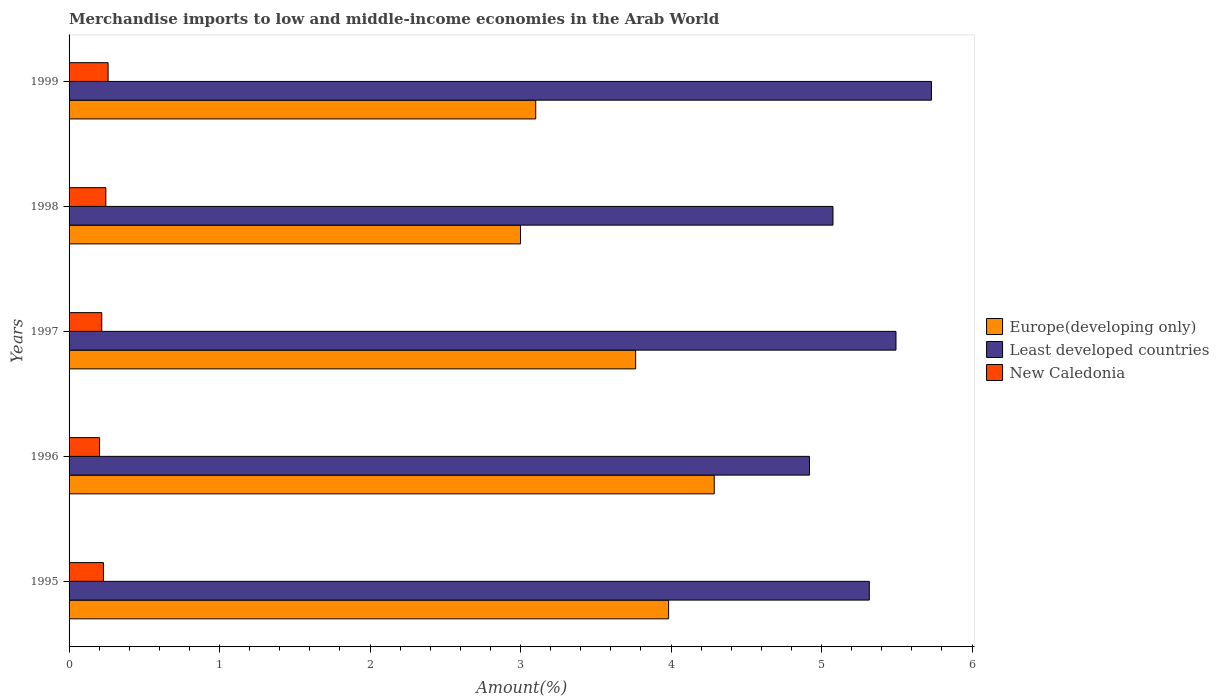How many different coloured bars are there?
Your answer should be very brief. 3. Are the number of bars per tick equal to the number of legend labels?
Your answer should be compact. Yes. Are the number of bars on each tick of the Y-axis equal?
Ensure brevity in your answer.  Yes. How many bars are there on the 5th tick from the top?
Give a very brief answer. 3. What is the label of the 5th group of bars from the top?
Provide a succinct answer. 1995. In how many cases, is the number of bars for a given year not equal to the number of legend labels?
Give a very brief answer. 0. What is the percentage of amount earned from merchandise imports in Europe(developing only) in 1997?
Your response must be concise. 3.76. Across all years, what is the maximum percentage of amount earned from merchandise imports in New Caledonia?
Your answer should be very brief. 0.26. Across all years, what is the minimum percentage of amount earned from merchandise imports in Europe(developing only)?
Offer a very short reply. 3. In which year was the percentage of amount earned from merchandise imports in Europe(developing only) maximum?
Offer a terse response. 1996. In which year was the percentage of amount earned from merchandise imports in New Caledonia minimum?
Provide a short and direct response. 1996. What is the total percentage of amount earned from merchandise imports in Least developed countries in the graph?
Offer a terse response. 26.54. What is the difference between the percentage of amount earned from merchandise imports in Europe(developing only) in 1998 and that in 1999?
Provide a succinct answer. -0.1. What is the difference between the percentage of amount earned from merchandise imports in Europe(developing only) in 1996 and the percentage of amount earned from merchandise imports in New Caledonia in 1997?
Make the answer very short. 4.07. What is the average percentage of amount earned from merchandise imports in Least developed countries per year?
Make the answer very short. 5.31. In the year 1996, what is the difference between the percentage of amount earned from merchandise imports in New Caledonia and percentage of amount earned from merchandise imports in Europe(developing only)?
Make the answer very short. -4.08. What is the ratio of the percentage of amount earned from merchandise imports in New Caledonia in 1997 to that in 1998?
Ensure brevity in your answer.  0.89. Is the percentage of amount earned from merchandise imports in Least developed countries in 1995 less than that in 1997?
Ensure brevity in your answer.  Yes. Is the difference between the percentage of amount earned from merchandise imports in New Caledonia in 1998 and 1999 greater than the difference between the percentage of amount earned from merchandise imports in Europe(developing only) in 1998 and 1999?
Make the answer very short. Yes. What is the difference between the highest and the second highest percentage of amount earned from merchandise imports in Europe(developing only)?
Offer a very short reply. 0.3. What is the difference between the highest and the lowest percentage of amount earned from merchandise imports in New Caledonia?
Keep it short and to the point. 0.06. In how many years, is the percentage of amount earned from merchandise imports in Least developed countries greater than the average percentage of amount earned from merchandise imports in Least developed countries taken over all years?
Your response must be concise. 3. Is the sum of the percentage of amount earned from merchandise imports in Europe(developing only) in 1998 and 1999 greater than the maximum percentage of amount earned from merchandise imports in Least developed countries across all years?
Your answer should be compact. Yes. What does the 3rd bar from the top in 1997 represents?
Make the answer very short. Europe(developing only). What does the 2nd bar from the bottom in 1999 represents?
Offer a very short reply. Least developed countries. Are all the bars in the graph horizontal?
Provide a short and direct response. Yes. How many years are there in the graph?
Provide a succinct answer. 5. What is the difference between two consecutive major ticks on the X-axis?
Your answer should be compact. 1. Are the values on the major ticks of X-axis written in scientific E-notation?
Keep it short and to the point. No. Does the graph contain any zero values?
Offer a very short reply. No. Does the graph contain grids?
Give a very brief answer. No. What is the title of the graph?
Offer a terse response. Merchandise imports to low and middle-income economies in the Arab World. What is the label or title of the X-axis?
Make the answer very short. Amount(%). What is the Amount(%) of Europe(developing only) in 1995?
Provide a short and direct response. 3.98. What is the Amount(%) in Least developed countries in 1995?
Provide a succinct answer. 5.32. What is the Amount(%) of New Caledonia in 1995?
Offer a very short reply. 0.23. What is the Amount(%) in Europe(developing only) in 1996?
Provide a succinct answer. 4.29. What is the Amount(%) of Least developed countries in 1996?
Keep it short and to the point. 4.92. What is the Amount(%) of New Caledonia in 1996?
Your response must be concise. 0.2. What is the Amount(%) in Europe(developing only) in 1997?
Offer a terse response. 3.76. What is the Amount(%) of Least developed countries in 1997?
Your answer should be compact. 5.49. What is the Amount(%) in New Caledonia in 1997?
Provide a short and direct response. 0.22. What is the Amount(%) of Europe(developing only) in 1998?
Your answer should be very brief. 3. What is the Amount(%) in Least developed countries in 1998?
Offer a terse response. 5.08. What is the Amount(%) of New Caledonia in 1998?
Provide a short and direct response. 0.24. What is the Amount(%) in Europe(developing only) in 1999?
Provide a short and direct response. 3.1. What is the Amount(%) in Least developed countries in 1999?
Keep it short and to the point. 5.73. What is the Amount(%) in New Caledonia in 1999?
Provide a succinct answer. 0.26. Across all years, what is the maximum Amount(%) in Europe(developing only)?
Your answer should be compact. 4.29. Across all years, what is the maximum Amount(%) in Least developed countries?
Your answer should be compact. 5.73. Across all years, what is the maximum Amount(%) in New Caledonia?
Your answer should be compact. 0.26. Across all years, what is the minimum Amount(%) of Europe(developing only)?
Make the answer very short. 3. Across all years, what is the minimum Amount(%) in Least developed countries?
Your response must be concise. 4.92. Across all years, what is the minimum Amount(%) of New Caledonia?
Keep it short and to the point. 0.2. What is the total Amount(%) in Europe(developing only) in the graph?
Provide a succinct answer. 18.14. What is the total Amount(%) of Least developed countries in the graph?
Your answer should be compact. 26.54. What is the total Amount(%) in New Caledonia in the graph?
Provide a succinct answer. 1.15. What is the difference between the Amount(%) of Europe(developing only) in 1995 and that in 1996?
Ensure brevity in your answer.  -0.3. What is the difference between the Amount(%) in Least developed countries in 1995 and that in 1996?
Ensure brevity in your answer.  0.4. What is the difference between the Amount(%) of New Caledonia in 1995 and that in 1996?
Ensure brevity in your answer.  0.03. What is the difference between the Amount(%) in Europe(developing only) in 1995 and that in 1997?
Your answer should be compact. 0.22. What is the difference between the Amount(%) in Least developed countries in 1995 and that in 1997?
Provide a short and direct response. -0.18. What is the difference between the Amount(%) in New Caledonia in 1995 and that in 1997?
Provide a succinct answer. 0.01. What is the difference between the Amount(%) of Europe(developing only) in 1995 and that in 1998?
Keep it short and to the point. 0.98. What is the difference between the Amount(%) of Least developed countries in 1995 and that in 1998?
Make the answer very short. 0.24. What is the difference between the Amount(%) of New Caledonia in 1995 and that in 1998?
Give a very brief answer. -0.02. What is the difference between the Amount(%) in Europe(developing only) in 1995 and that in 1999?
Offer a very short reply. 0.88. What is the difference between the Amount(%) in Least developed countries in 1995 and that in 1999?
Provide a short and direct response. -0.41. What is the difference between the Amount(%) in New Caledonia in 1995 and that in 1999?
Give a very brief answer. -0.03. What is the difference between the Amount(%) in Europe(developing only) in 1996 and that in 1997?
Your response must be concise. 0.52. What is the difference between the Amount(%) in Least developed countries in 1996 and that in 1997?
Your answer should be very brief. -0.57. What is the difference between the Amount(%) of New Caledonia in 1996 and that in 1997?
Your answer should be compact. -0.01. What is the difference between the Amount(%) in Europe(developing only) in 1996 and that in 1998?
Ensure brevity in your answer.  1.29. What is the difference between the Amount(%) of Least developed countries in 1996 and that in 1998?
Your answer should be very brief. -0.16. What is the difference between the Amount(%) in New Caledonia in 1996 and that in 1998?
Provide a short and direct response. -0.04. What is the difference between the Amount(%) in Europe(developing only) in 1996 and that in 1999?
Provide a short and direct response. 1.19. What is the difference between the Amount(%) in Least developed countries in 1996 and that in 1999?
Give a very brief answer. -0.81. What is the difference between the Amount(%) in New Caledonia in 1996 and that in 1999?
Provide a short and direct response. -0.06. What is the difference between the Amount(%) in Europe(developing only) in 1997 and that in 1998?
Your answer should be very brief. 0.77. What is the difference between the Amount(%) of Least developed countries in 1997 and that in 1998?
Offer a terse response. 0.42. What is the difference between the Amount(%) in New Caledonia in 1997 and that in 1998?
Your answer should be compact. -0.03. What is the difference between the Amount(%) in Europe(developing only) in 1997 and that in 1999?
Make the answer very short. 0.66. What is the difference between the Amount(%) of Least developed countries in 1997 and that in 1999?
Give a very brief answer. -0.24. What is the difference between the Amount(%) of New Caledonia in 1997 and that in 1999?
Your answer should be very brief. -0.04. What is the difference between the Amount(%) of Europe(developing only) in 1998 and that in 1999?
Provide a succinct answer. -0.1. What is the difference between the Amount(%) in Least developed countries in 1998 and that in 1999?
Your answer should be very brief. -0.65. What is the difference between the Amount(%) of New Caledonia in 1998 and that in 1999?
Give a very brief answer. -0.01. What is the difference between the Amount(%) in Europe(developing only) in 1995 and the Amount(%) in Least developed countries in 1996?
Provide a succinct answer. -0.94. What is the difference between the Amount(%) in Europe(developing only) in 1995 and the Amount(%) in New Caledonia in 1996?
Your response must be concise. 3.78. What is the difference between the Amount(%) in Least developed countries in 1995 and the Amount(%) in New Caledonia in 1996?
Provide a succinct answer. 5.12. What is the difference between the Amount(%) of Europe(developing only) in 1995 and the Amount(%) of Least developed countries in 1997?
Give a very brief answer. -1.51. What is the difference between the Amount(%) of Europe(developing only) in 1995 and the Amount(%) of New Caledonia in 1997?
Your answer should be compact. 3.77. What is the difference between the Amount(%) of Least developed countries in 1995 and the Amount(%) of New Caledonia in 1997?
Make the answer very short. 5.1. What is the difference between the Amount(%) of Europe(developing only) in 1995 and the Amount(%) of Least developed countries in 1998?
Give a very brief answer. -1.09. What is the difference between the Amount(%) of Europe(developing only) in 1995 and the Amount(%) of New Caledonia in 1998?
Offer a terse response. 3.74. What is the difference between the Amount(%) in Least developed countries in 1995 and the Amount(%) in New Caledonia in 1998?
Your answer should be compact. 5.07. What is the difference between the Amount(%) of Europe(developing only) in 1995 and the Amount(%) of Least developed countries in 1999?
Your answer should be compact. -1.75. What is the difference between the Amount(%) in Europe(developing only) in 1995 and the Amount(%) in New Caledonia in 1999?
Your answer should be very brief. 3.72. What is the difference between the Amount(%) in Least developed countries in 1995 and the Amount(%) in New Caledonia in 1999?
Your answer should be very brief. 5.06. What is the difference between the Amount(%) of Europe(developing only) in 1996 and the Amount(%) of Least developed countries in 1997?
Your answer should be very brief. -1.21. What is the difference between the Amount(%) in Europe(developing only) in 1996 and the Amount(%) in New Caledonia in 1997?
Your answer should be compact. 4.07. What is the difference between the Amount(%) of Least developed countries in 1996 and the Amount(%) of New Caledonia in 1997?
Offer a terse response. 4.7. What is the difference between the Amount(%) of Europe(developing only) in 1996 and the Amount(%) of Least developed countries in 1998?
Your response must be concise. -0.79. What is the difference between the Amount(%) of Europe(developing only) in 1996 and the Amount(%) of New Caledonia in 1998?
Provide a succinct answer. 4.04. What is the difference between the Amount(%) in Least developed countries in 1996 and the Amount(%) in New Caledonia in 1998?
Your answer should be compact. 4.68. What is the difference between the Amount(%) of Europe(developing only) in 1996 and the Amount(%) of Least developed countries in 1999?
Your answer should be very brief. -1.44. What is the difference between the Amount(%) of Europe(developing only) in 1996 and the Amount(%) of New Caledonia in 1999?
Provide a short and direct response. 4.03. What is the difference between the Amount(%) of Least developed countries in 1996 and the Amount(%) of New Caledonia in 1999?
Your response must be concise. 4.66. What is the difference between the Amount(%) of Europe(developing only) in 1997 and the Amount(%) of Least developed countries in 1998?
Provide a short and direct response. -1.31. What is the difference between the Amount(%) in Europe(developing only) in 1997 and the Amount(%) in New Caledonia in 1998?
Make the answer very short. 3.52. What is the difference between the Amount(%) in Least developed countries in 1997 and the Amount(%) in New Caledonia in 1998?
Offer a terse response. 5.25. What is the difference between the Amount(%) in Europe(developing only) in 1997 and the Amount(%) in Least developed countries in 1999?
Your response must be concise. -1.97. What is the difference between the Amount(%) of Europe(developing only) in 1997 and the Amount(%) of New Caledonia in 1999?
Keep it short and to the point. 3.51. What is the difference between the Amount(%) of Least developed countries in 1997 and the Amount(%) of New Caledonia in 1999?
Keep it short and to the point. 5.24. What is the difference between the Amount(%) of Europe(developing only) in 1998 and the Amount(%) of Least developed countries in 1999?
Give a very brief answer. -2.73. What is the difference between the Amount(%) of Europe(developing only) in 1998 and the Amount(%) of New Caledonia in 1999?
Your response must be concise. 2.74. What is the difference between the Amount(%) of Least developed countries in 1998 and the Amount(%) of New Caledonia in 1999?
Make the answer very short. 4.82. What is the average Amount(%) in Europe(developing only) per year?
Ensure brevity in your answer.  3.63. What is the average Amount(%) in Least developed countries per year?
Give a very brief answer. 5.31. What is the average Amount(%) in New Caledonia per year?
Offer a terse response. 0.23. In the year 1995, what is the difference between the Amount(%) of Europe(developing only) and Amount(%) of Least developed countries?
Provide a succinct answer. -1.33. In the year 1995, what is the difference between the Amount(%) of Europe(developing only) and Amount(%) of New Caledonia?
Your answer should be compact. 3.76. In the year 1995, what is the difference between the Amount(%) in Least developed countries and Amount(%) in New Caledonia?
Make the answer very short. 5.09. In the year 1996, what is the difference between the Amount(%) of Europe(developing only) and Amount(%) of Least developed countries?
Give a very brief answer. -0.63. In the year 1996, what is the difference between the Amount(%) in Europe(developing only) and Amount(%) in New Caledonia?
Your answer should be very brief. 4.08. In the year 1996, what is the difference between the Amount(%) of Least developed countries and Amount(%) of New Caledonia?
Your answer should be very brief. 4.72. In the year 1997, what is the difference between the Amount(%) of Europe(developing only) and Amount(%) of Least developed countries?
Your answer should be very brief. -1.73. In the year 1997, what is the difference between the Amount(%) of Europe(developing only) and Amount(%) of New Caledonia?
Your response must be concise. 3.55. In the year 1997, what is the difference between the Amount(%) of Least developed countries and Amount(%) of New Caledonia?
Your response must be concise. 5.28. In the year 1998, what is the difference between the Amount(%) of Europe(developing only) and Amount(%) of Least developed countries?
Provide a short and direct response. -2.08. In the year 1998, what is the difference between the Amount(%) in Europe(developing only) and Amount(%) in New Caledonia?
Your answer should be compact. 2.76. In the year 1998, what is the difference between the Amount(%) of Least developed countries and Amount(%) of New Caledonia?
Provide a succinct answer. 4.83. In the year 1999, what is the difference between the Amount(%) of Europe(developing only) and Amount(%) of Least developed countries?
Your answer should be very brief. -2.63. In the year 1999, what is the difference between the Amount(%) of Europe(developing only) and Amount(%) of New Caledonia?
Ensure brevity in your answer.  2.84. In the year 1999, what is the difference between the Amount(%) of Least developed countries and Amount(%) of New Caledonia?
Provide a succinct answer. 5.47. What is the ratio of the Amount(%) of Europe(developing only) in 1995 to that in 1996?
Your response must be concise. 0.93. What is the ratio of the Amount(%) in Least developed countries in 1995 to that in 1996?
Provide a succinct answer. 1.08. What is the ratio of the Amount(%) in New Caledonia in 1995 to that in 1996?
Your answer should be very brief. 1.13. What is the ratio of the Amount(%) of Europe(developing only) in 1995 to that in 1997?
Offer a very short reply. 1.06. What is the ratio of the Amount(%) in Least developed countries in 1995 to that in 1997?
Your answer should be compact. 0.97. What is the ratio of the Amount(%) of New Caledonia in 1995 to that in 1997?
Your answer should be very brief. 1.05. What is the ratio of the Amount(%) in Europe(developing only) in 1995 to that in 1998?
Your response must be concise. 1.33. What is the ratio of the Amount(%) of Least developed countries in 1995 to that in 1998?
Offer a very short reply. 1.05. What is the ratio of the Amount(%) of New Caledonia in 1995 to that in 1998?
Keep it short and to the point. 0.93. What is the ratio of the Amount(%) of Europe(developing only) in 1995 to that in 1999?
Your answer should be very brief. 1.28. What is the ratio of the Amount(%) of Least developed countries in 1995 to that in 1999?
Your answer should be compact. 0.93. What is the ratio of the Amount(%) in New Caledonia in 1995 to that in 1999?
Your answer should be compact. 0.88. What is the ratio of the Amount(%) of Europe(developing only) in 1996 to that in 1997?
Keep it short and to the point. 1.14. What is the ratio of the Amount(%) in Least developed countries in 1996 to that in 1997?
Make the answer very short. 0.9. What is the ratio of the Amount(%) in New Caledonia in 1996 to that in 1997?
Give a very brief answer. 0.93. What is the ratio of the Amount(%) of Europe(developing only) in 1996 to that in 1998?
Offer a terse response. 1.43. What is the ratio of the Amount(%) of Least developed countries in 1996 to that in 1998?
Your answer should be compact. 0.97. What is the ratio of the Amount(%) of New Caledonia in 1996 to that in 1998?
Your answer should be compact. 0.83. What is the ratio of the Amount(%) in Europe(developing only) in 1996 to that in 1999?
Give a very brief answer. 1.38. What is the ratio of the Amount(%) in Least developed countries in 1996 to that in 1999?
Your response must be concise. 0.86. What is the ratio of the Amount(%) of New Caledonia in 1996 to that in 1999?
Make the answer very short. 0.78. What is the ratio of the Amount(%) of Europe(developing only) in 1997 to that in 1998?
Keep it short and to the point. 1.25. What is the ratio of the Amount(%) of Least developed countries in 1997 to that in 1998?
Provide a succinct answer. 1.08. What is the ratio of the Amount(%) in New Caledonia in 1997 to that in 1998?
Your answer should be compact. 0.89. What is the ratio of the Amount(%) of Europe(developing only) in 1997 to that in 1999?
Keep it short and to the point. 1.21. What is the ratio of the Amount(%) of Least developed countries in 1997 to that in 1999?
Ensure brevity in your answer.  0.96. What is the ratio of the Amount(%) of New Caledonia in 1997 to that in 1999?
Offer a terse response. 0.84. What is the ratio of the Amount(%) in Europe(developing only) in 1998 to that in 1999?
Your answer should be compact. 0.97. What is the ratio of the Amount(%) of Least developed countries in 1998 to that in 1999?
Offer a very short reply. 0.89. What is the ratio of the Amount(%) of New Caledonia in 1998 to that in 1999?
Ensure brevity in your answer.  0.94. What is the difference between the highest and the second highest Amount(%) of Europe(developing only)?
Give a very brief answer. 0.3. What is the difference between the highest and the second highest Amount(%) of Least developed countries?
Offer a terse response. 0.24. What is the difference between the highest and the second highest Amount(%) in New Caledonia?
Keep it short and to the point. 0.01. What is the difference between the highest and the lowest Amount(%) in Europe(developing only)?
Your answer should be compact. 1.29. What is the difference between the highest and the lowest Amount(%) in Least developed countries?
Provide a short and direct response. 0.81. What is the difference between the highest and the lowest Amount(%) of New Caledonia?
Provide a succinct answer. 0.06. 